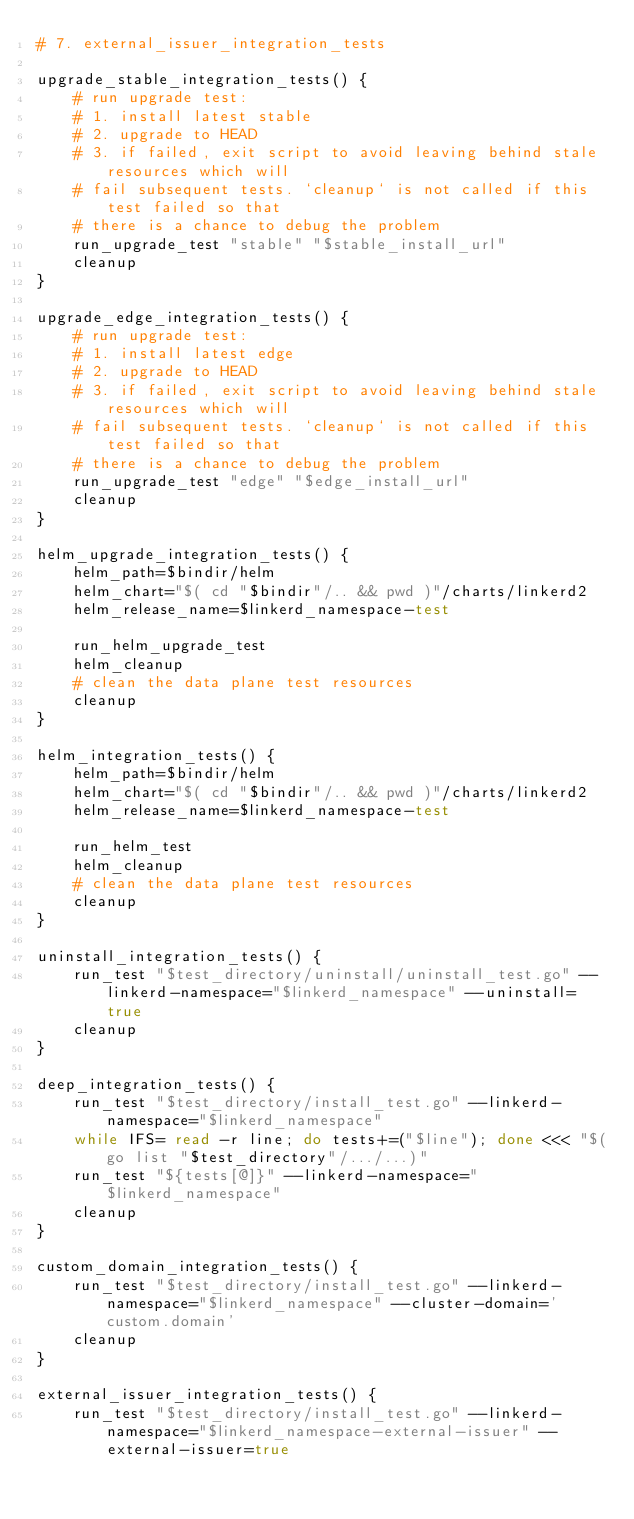<code> <loc_0><loc_0><loc_500><loc_500><_Bash_># 7. external_issuer_integration_tests

upgrade_stable_integration_tests() {
    # run upgrade test:
    # 1. install latest stable
    # 2. upgrade to HEAD
    # 3. if failed, exit script to avoid leaving behind stale resources which will
    # fail subsequent tests. `cleanup` is not called if this test failed so that
    # there is a chance to debug the problem
    run_upgrade_test "stable" "$stable_install_url"
    cleanup
}

upgrade_edge_integration_tests() {
    # run upgrade test:
    # 1. install latest edge
    # 2. upgrade to HEAD
    # 3. if failed, exit script to avoid leaving behind stale resources which will
    # fail subsequent tests. `cleanup` is not called if this test failed so that
    # there is a chance to debug the problem
    run_upgrade_test "edge" "$edge_install_url"
    cleanup
}

helm_upgrade_integration_tests() {
    helm_path=$bindir/helm
    helm_chart="$( cd "$bindir"/.. && pwd )"/charts/linkerd2
    helm_release_name=$linkerd_namespace-test

    run_helm_upgrade_test
    helm_cleanup
    # clean the data plane test resources
    cleanup
}

helm_integration_tests() {
    helm_path=$bindir/helm
    helm_chart="$( cd "$bindir"/.. && pwd )"/charts/linkerd2
    helm_release_name=$linkerd_namespace-test

    run_helm_test
    helm_cleanup
    # clean the data plane test resources
    cleanup
}

uninstall_integration_tests() {
    run_test "$test_directory/uninstall/uninstall_test.go" --linkerd-namespace="$linkerd_namespace" --uninstall=true
    cleanup
}

deep_integration_tests() {
    run_test "$test_directory/install_test.go" --linkerd-namespace="$linkerd_namespace"
    while IFS= read -r line; do tests+=("$line"); done <<< "$(go list "$test_directory"/.../...)"
    run_test "${tests[@]}" --linkerd-namespace="$linkerd_namespace"
    cleanup
}

custom_domain_integration_tests() {
    run_test "$test_directory/install_test.go" --linkerd-namespace="$linkerd_namespace" --cluster-domain='custom.domain'
    cleanup
}

external_issuer_integration_tests() {
    run_test "$test_directory/install_test.go" --linkerd-namespace="$linkerd_namespace-external-issuer" --external-issuer=true</code> 